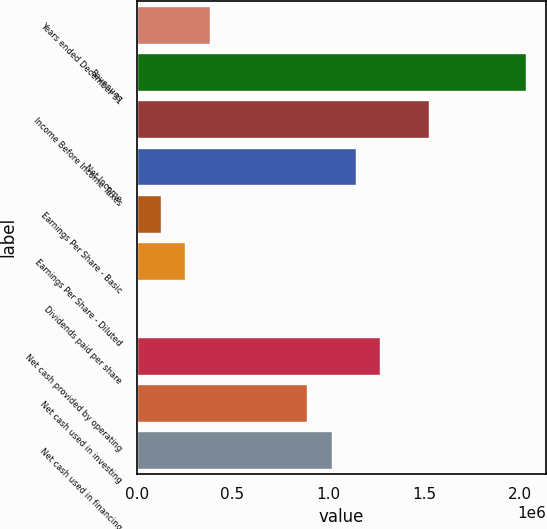Convert chart to OTSL. <chart><loc_0><loc_0><loc_500><loc_500><bar_chart><fcel>Years ended December 31<fcel>Revenues<fcel>Income Before Income Taxes<fcel>Net Income<fcel>Earnings Per Share - Basic<fcel>Earnings Per Share - Diluted<fcel>Dividends paid per share<fcel>Net cash provided by operating<fcel>Net cash used in investing<fcel>Net cash used in financing<nl><fcel>381273<fcel>2.03345e+06<fcel>1.52509e+06<fcel>1.14382e+06<fcel>127091<fcel>254182<fcel>0.44<fcel>1.27091e+06<fcel>889636<fcel>1.01673e+06<nl></chart> 